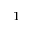<formula> <loc_0><loc_0><loc_500><loc_500>^ { 1 }</formula> 